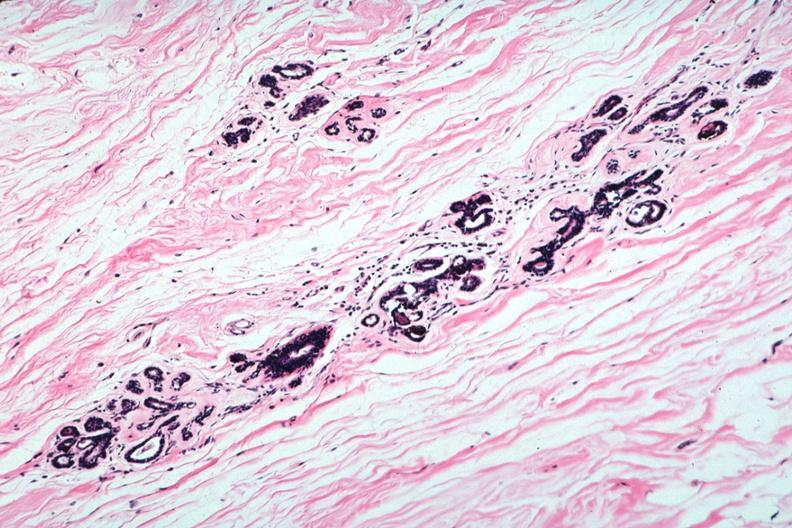where is this area in the body?
Answer the question using a single word or phrase. Breast 